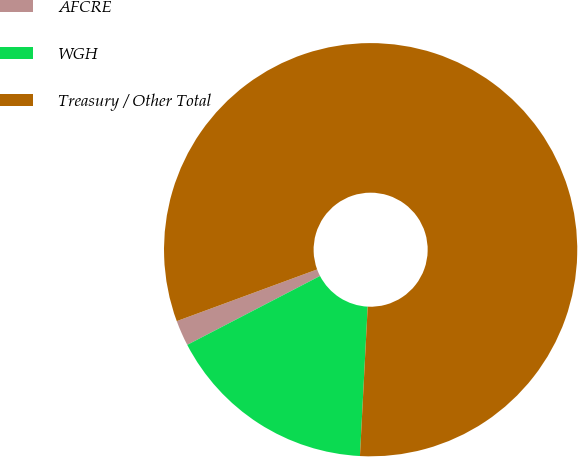<chart> <loc_0><loc_0><loc_500><loc_500><pie_chart><fcel>AFCRE<fcel>WGH<fcel>Treasury / Other Total<nl><fcel>2.0%<fcel>16.56%<fcel>81.45%<nl></chart> 